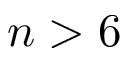Convert formula to latex. <formula><loc_0><loc_0><loc_500><loc_500>n > 6</formula> 